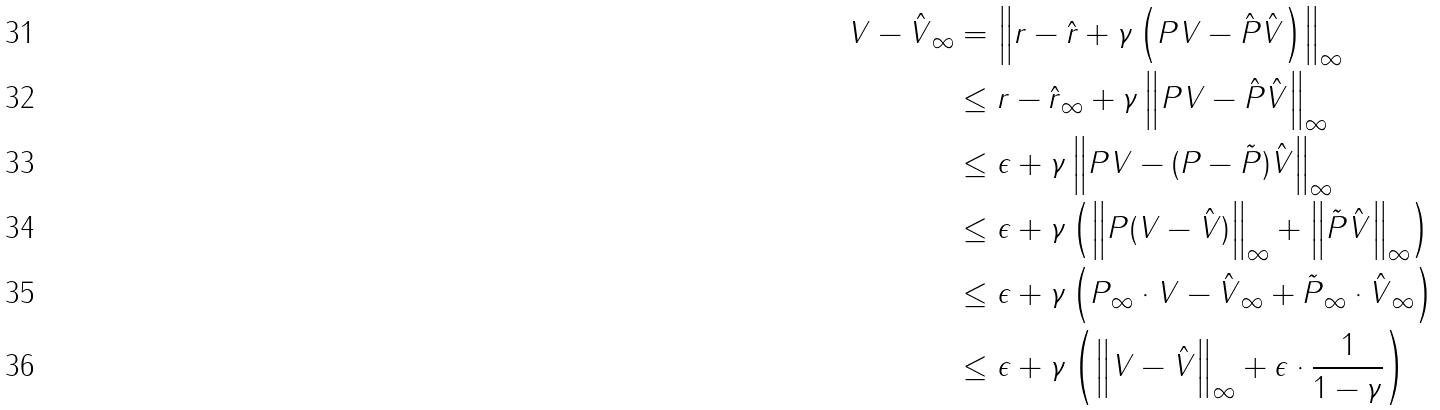Convert formula to latex. <formula><loc_0><loc_0><loc_500><loc_500>\| V - \hat { V } \| _ { \infty } & = \left \| r - \hat { r } + \gamma \left ( P V - \hat { P } \hat { V } \right ) \right \| _ { \infty } \\ & \leq \| r - \hat { r } \| _ { \infty } + \gamma \left \| P V - \hat { P } \hat { V } \right \| _ { \infty } \\ & \leq \epsilon + \gamma \left \| P V - ( P - \tilde { P } ) \hat { V } \right \| _ { \infty } \\ & \leq \epsilon + \gamma \left ( \left \| P ( V - \hat { V } ) \right \| _ { \infty } + \left \| \tilde { P } \hat { V } \right \| _ { \infty } \right ) \\ & \leq \epsilon + \gamma \left ( \| P \| _ { \infty } \cdot \| V - \hat { V } \| _ { \infty } + \| \tilde { P } \| _ { \infty } \cdot \| \hat { V } \| _ { \infty } \right ) \\ & \leq \epsilon + \gamma \left ( \left \| V - \hat { V } \right \| _ { \infty } + \epsilon \cdot \frac { 1 } { 1 - \gamma } \right )</formula> 